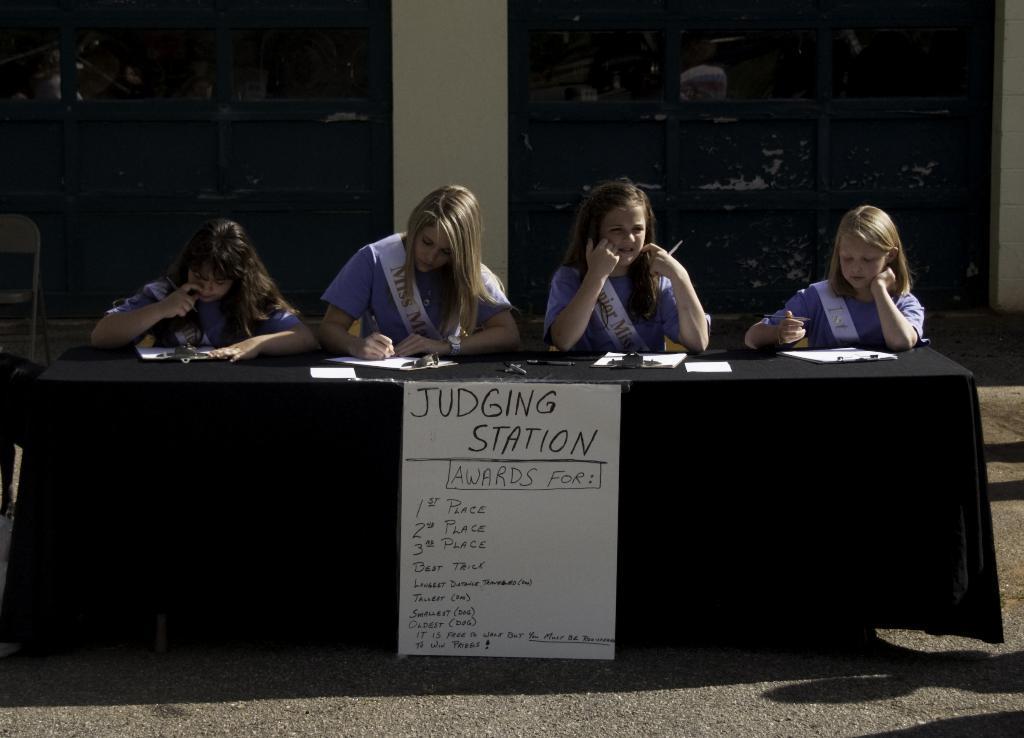Describe this image in one or two sentences. Here we can see four persons are sitting on the chairs. They are writing something on the paper. This is table. And there is a poster. This is road and there is a pillar. 